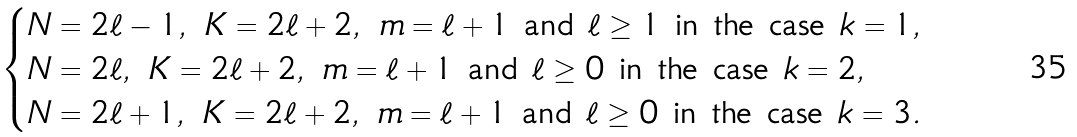<formula> <loc_0><loc_0><loc_500><loc_500>\begin{cases} N = 2 \ell - 1 , \ K = 2 \ell + 2 , \ m = \ell + 1 \text { and } \ell \geq 1 \text { in the case } k = 1 , \\ N = 2 \ell , \ K = 2 \ell + 2 , \ m = \ell + 1 \text { and } \ell \geq 0 \text { in the case } k = 2 , \\ N = 2 \ell + 1 , \ K = 2 \ell + 2 , \ m = \ell + 1 \text { and } \ell \geq 0 \text { in the case } k = 3 . \end{cases}</formula> 